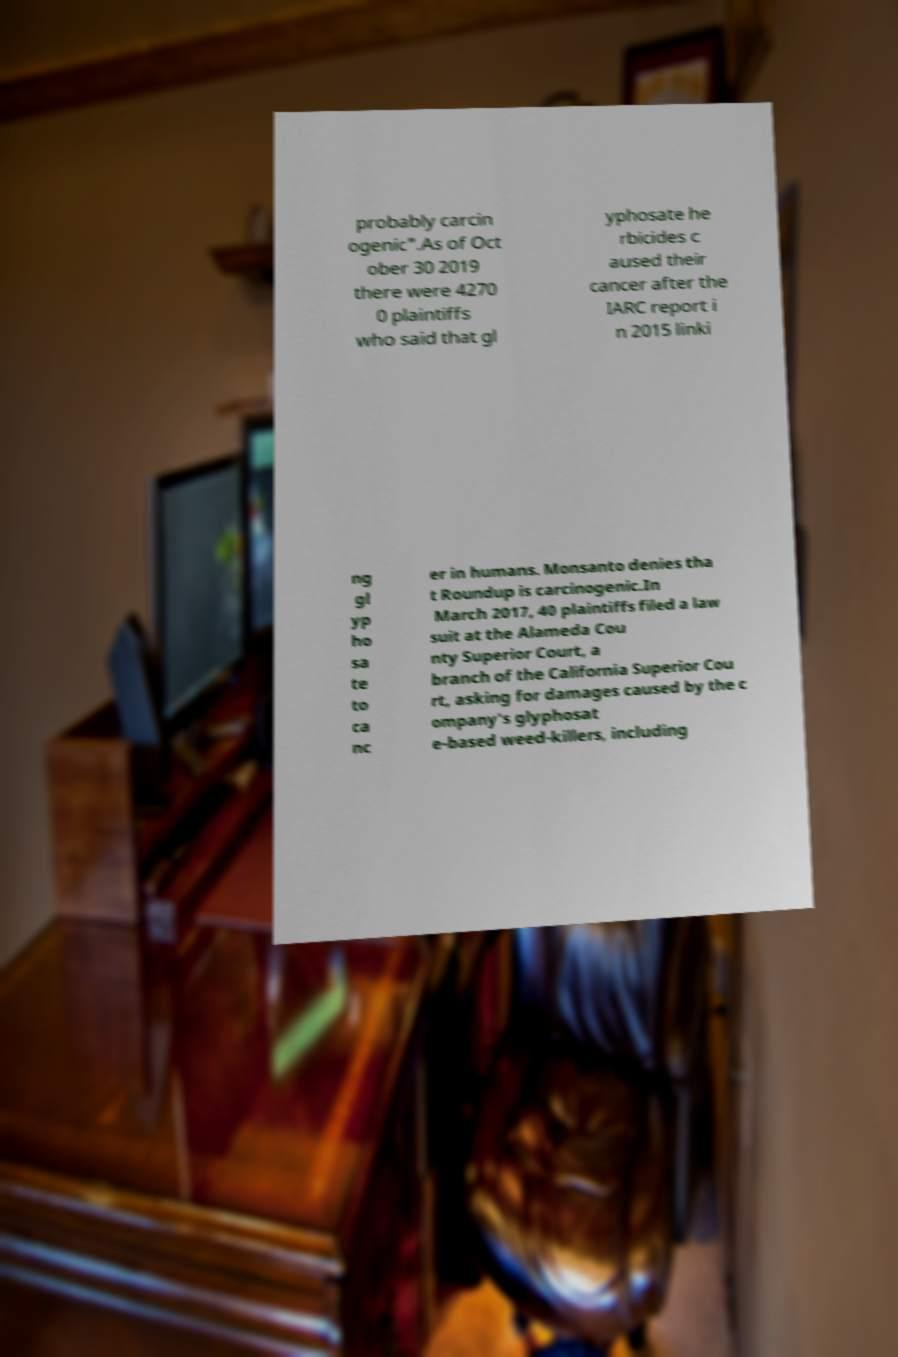Can you accurately transcribe the text from the provided image for me? probably carcin ogenic".As of Oct ober 30 2019 there were 4270 0 plaintiffs who said that gl yphosate he rbicides c aused their cancer after the IARC report i n 2015 linki ng gl yp ho sa te to ca nc er in humans. Monsanto denies tha t Roundup is carcinogenic.In March 2017, 40 plaintiffs filed a law suit at the Alameda Cou nty Superior Court, a branch of the California Superior Cou rt, asking for damages caused by the c ompany's glyphosat e-based weed-killers, including 